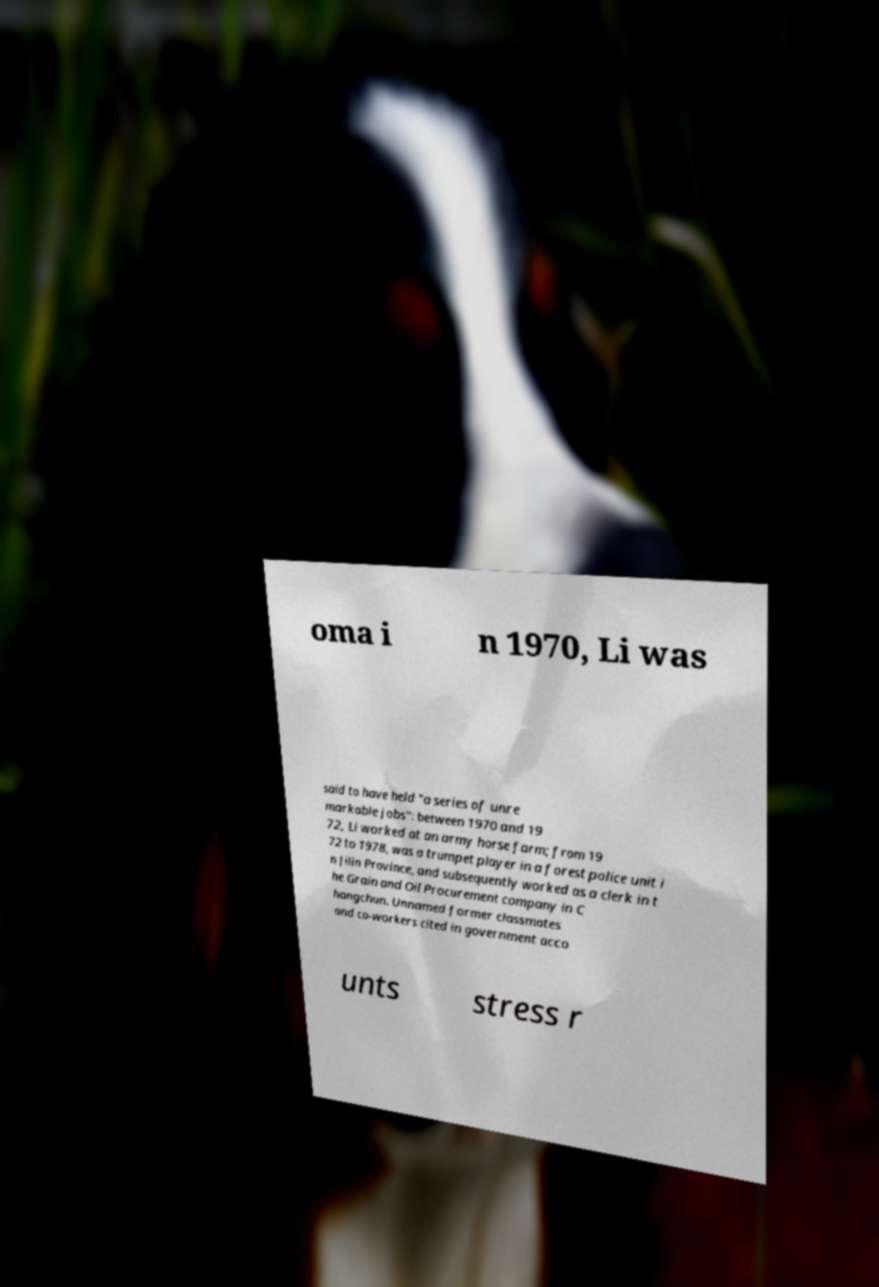I need the written content from this picture converted into text. Can you do that? oma i n 1970, Li was said to have held "a series of unre markable jobs": between 1970 and 19 72, Li worked at an army horse farm; from 19 72 to 1978, was a trumpet player in a forest police unit i n Jilin Province, and subsequently worked as a clerk in t he Grain and Oil Procurement company in C hangchun. Unnamed former classmates and co-workers cited in government acco unts stress r 